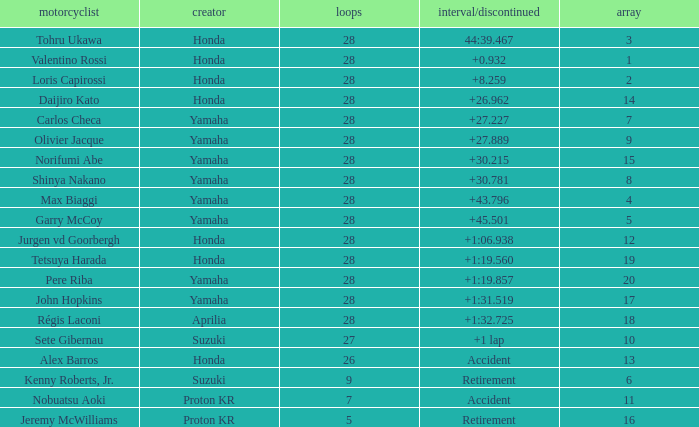Which Grid has Laps larger than 26, and a Time/Retired of 44:39.467? 3.0. Would you mind parsing the complete table? {'header': ['motorcyclist', 'creator', 'loops', 'interval/discontinued', 'array'], 'rows': [['Tohru Ukawa', 'Honda', '28', '44:39.467', '3'], ['Valentino Rossi', 'Honda', '28', '+0.932', '1'], ['Loris Capirossi', 'Honda', '28', '+8.259', '2'], ['Daijiro Kato', 'Honda', '28', '+26.962', '14'], ['Carlos Checa', 'Yamaha', '28', '+27.227', '7'], ['Olivier Jacque', 'Yamaha', '28', '+27.889', '9'], ['Norifumi Abe', 'Yamaha', '28', '+30.215', '15'], ['Shinya Nakano', 'Yamaha', '28', '+30.781', '8'], ['Max Biaggi', 'Yamaha', '28', '+43.796', '4'], ['Garry McCoy', 'Yamaha', '28', '+45.501', '5'], ['Jurgen vd Goorbergh', 'Honda', '28', '+1:06.938', '12'], ['Tetsuya Harada', 'Honda', '28', '+1:19.560', '19'], ['Pere Riba', 'Yamaha', '28', '+1:19.857', '20'], ['John Hopkins', 'Yamaha', '28', '+1:31.519', '17'], ['Régis Laconi', 'Aprilia', '28', '+1:32.725', '18'], ['Sete Gibernau', 'Suzuki', '27', '+1 lap', '10'], ['Alex Barros', 'Honda', '26', 'Accident', '13'], ['Kenny Roberts, Jr.', 'Suzuki', '9', 'Retirement', '6'], ['Nobuatsu Aoki', 'Proton KR', '7', 'Accident', '11'], ['Jeremy McWilliams', 'Proton KR', '5', 'Retirement', '16']]} 